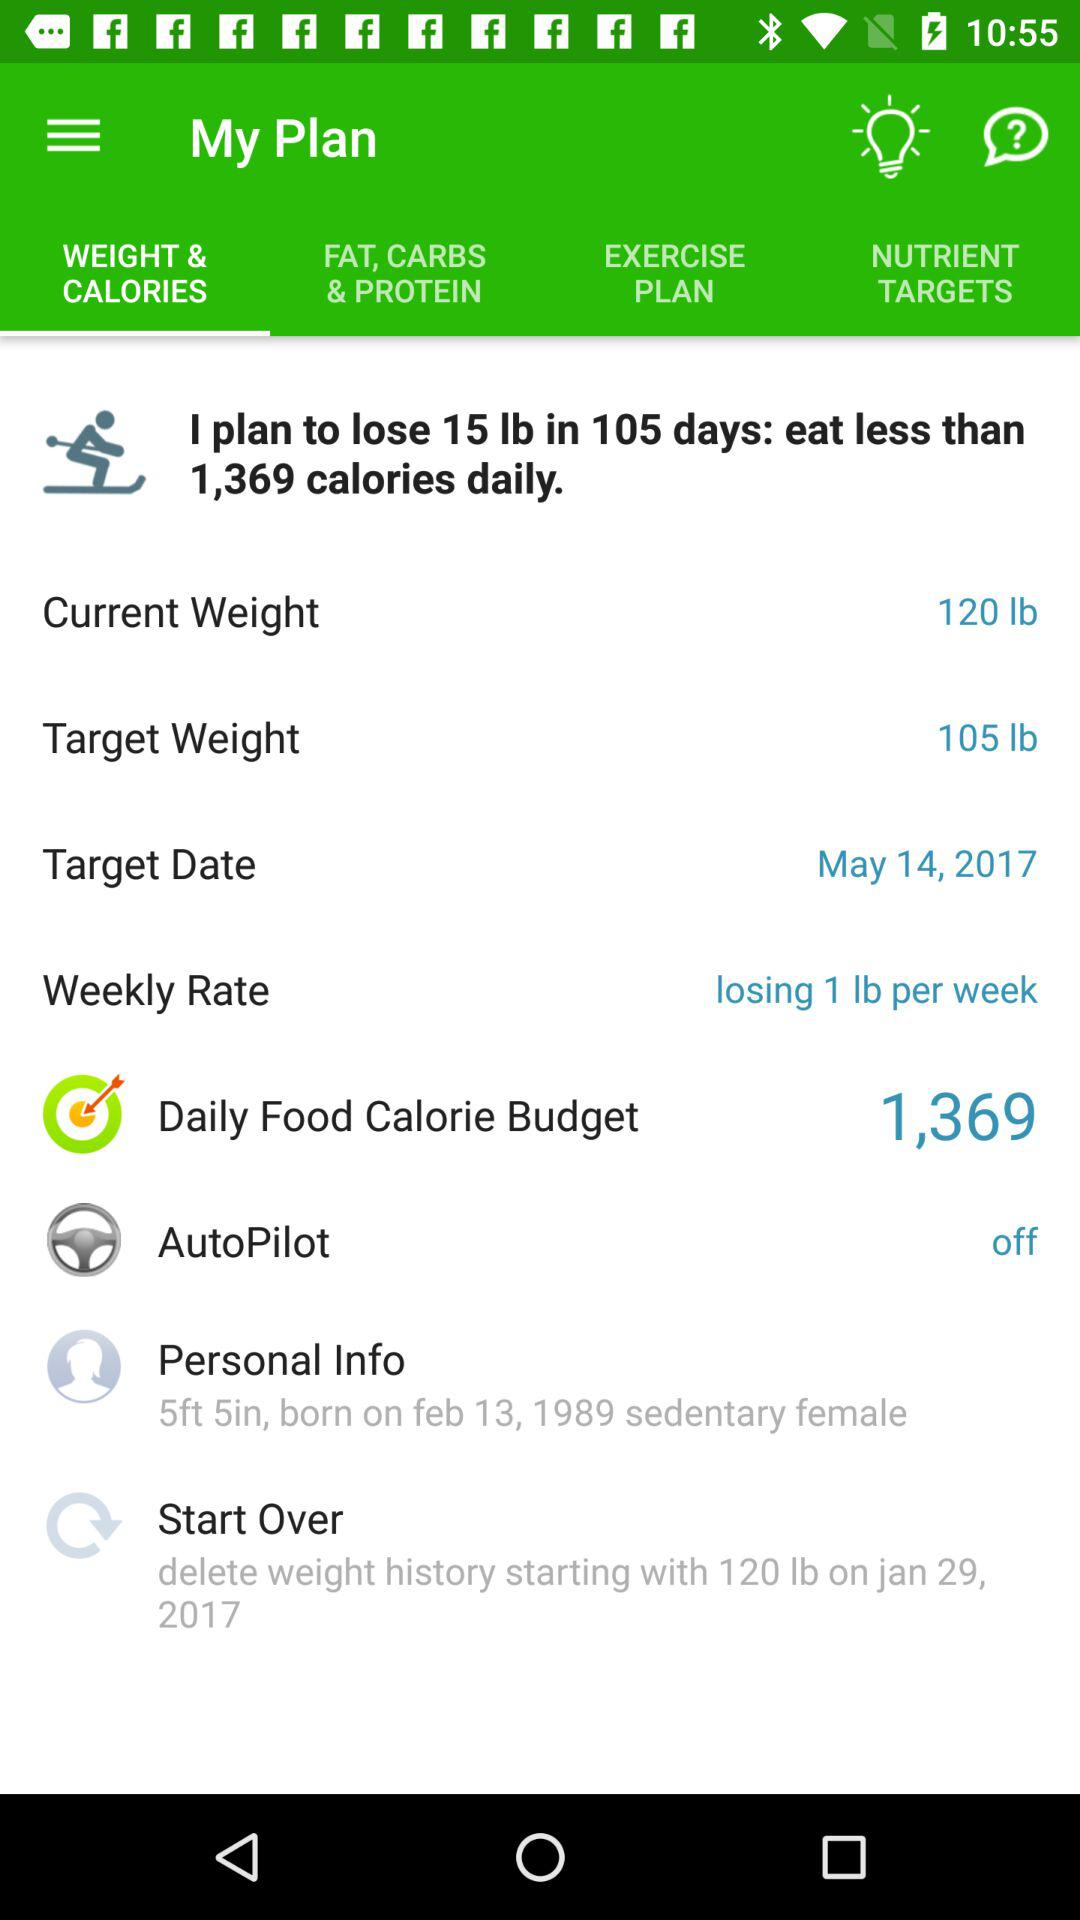How much weight do I want to lose in total?
Answer the question using a single word or phrase. 15 lb 